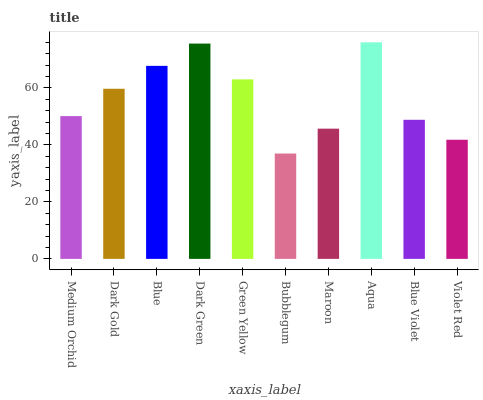Is Bubblegum the minimum?
Answer yes or no. Yes. Is Aqua the maximum?
Answer yes or no. Yes. Is Dark Gold the minimum?
Answer yes or no. No. Is Dark Gold the maximum?
Answer yes or no. No. Is Dark Gold greater than Medium Orchid?
Answer yes or no. Yes. Is Medium Orchid less than Dark Gold?
Answer yes or no. Yes. Is Medium Orchid greater than Dark Gold?
Answer yes or no. No. Is Dark Gold less than Medium Orchid?
Answer yes or no. No. Is Dark Gold the high median?
Answer yes or no. Yes. Is Medium Orchid the low median?
Answer yes or no. Yes. Is Bubblegum the high median?
Answer yes or no. No. Is Dark Green the low median?
Answer yes or no. No. 